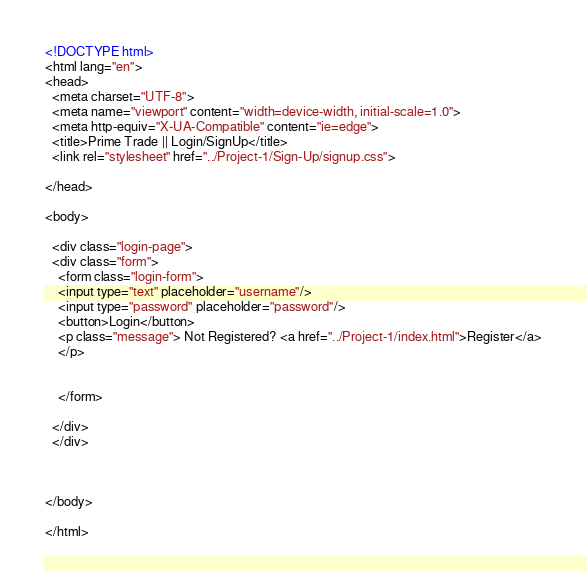<code> <loc_0><loc_0><loc_500><loc_500><_HTML_><!DOCTYPE html>
<html lang="en">
<head>
  <meta charset="UTF-8">
  <meta name="viewport" content="width=device-width, initial-scale=1.0">
  <meta http-equiv="X-UA-Compatible" content="ie=edge">
  <title>Prime Trade || Login/SignUp</title>
  <link rel="stylesheet" href="../Project-1/Sign-Up/signup.css">

</head>

<body>

  <div class="login-page">
  <div class="form">
    <form class="login-form">
    <input type="text" placeholder="username"/>
    <input type="password" placeholder="password"/>
    <button>Login</button>
    <p class="message"> Not Registered? <a href="../Project-1/index.html">Register</a>
    </p>


    </form>

  </div>
  </div>
    


</body>

</html></code> 